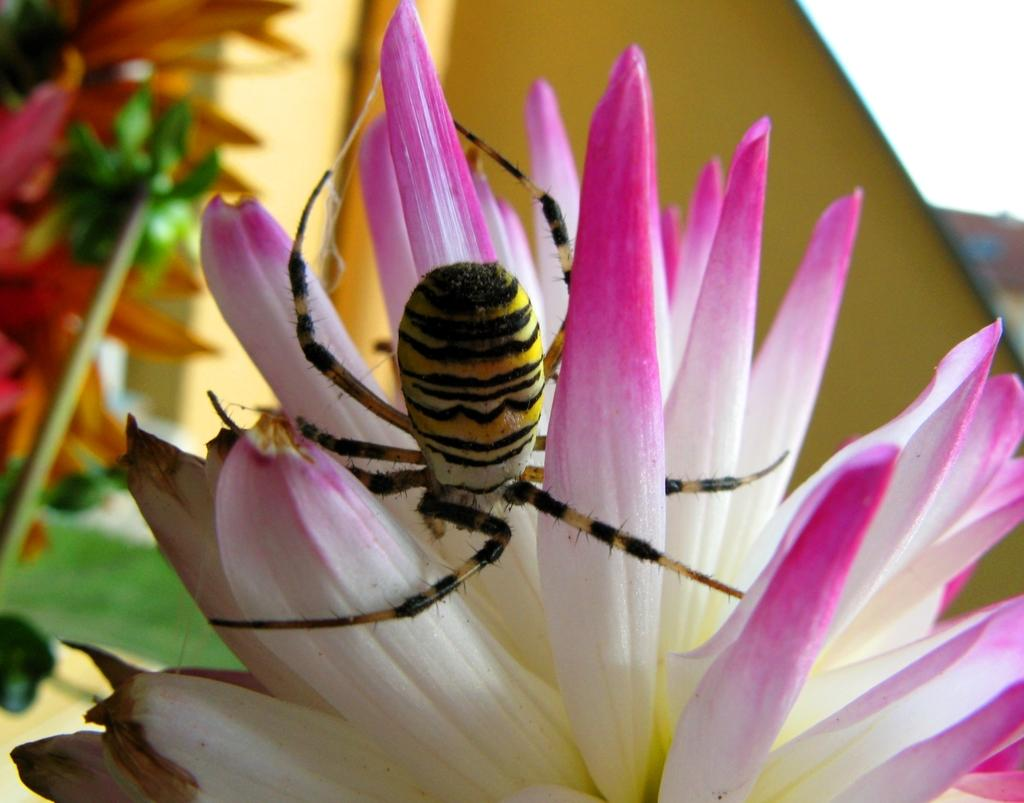What type of creature is present in the image? There is an insect in the image. Where is the insect located? The insect is on a flower. What type of paint is used to color the dolls in the image? There are no dolls present in the image, and therefore no paint can be observed. 